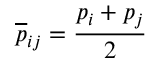Convert formula to latex. <formula><loc_0><loc_0><loc_500><loc_500>\overline { p } _ { i j } = \frac { p _ { i } + p _ { j } } { 2 }</formula> 